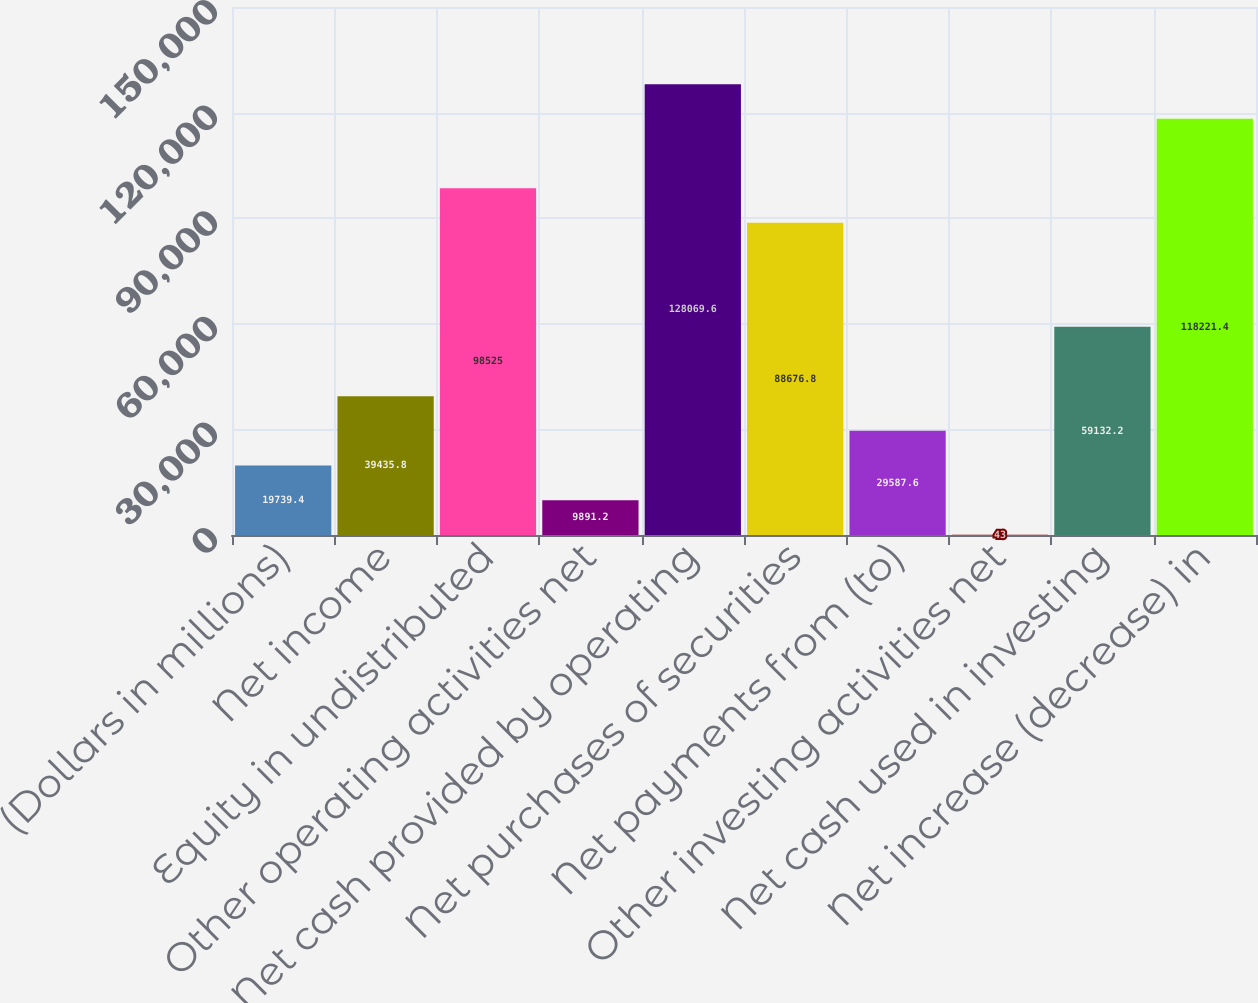Convert chart. <chart><loc_0><loc_0><loc_500><loc_500><bar_chart><fcel>(Dollars in millions)<fcel>Net income<fcel>Equity in undistributed<fcel>Other operating activities net<fcel>Net cash provided by operating<fcel>Net purchases of securities<fcel>Net payments from (to)<fcel>Other investing activities net<fcel>Net cash used in investing<fcel>Net increase (decrease) in<nl><fcel>19739.4<fcel>39435.8<fcel>98525<fcel>9891.2<fcel>128070<fcel>88676.8<fcel>29587.6<fcel>43<fcel>59132.2<fcel>118221<nl></chart> 